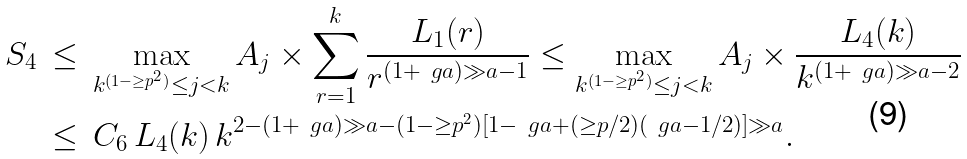<formula> <loc_0><loc_0><loc_500><loc_500>S _ { 4 } & \, \leq \, \max _ { k ^ { ( 1 - \geq p ^ { 2 } ) } \leq j < k } A _ { j } \times \sum _ { r = 1 } ^ { k } \frac { L _ { 1 } ( r ) } { r ^ { ( 1 + \ g a ) \gg a - 1 } } \leq \max _ { k ^ { ( 1 - \geq p ^ { 2 } ) } \leq j < k } A _ { j } \times \frac { L _ { 4 } ( k ) } { k ^ { ( 1 + \ g a ) \gg a - 2 } } \\ & \, \leq \, C _ { 6 } \, L _ { 4 } ( k ) \, k ^ { 2 - ( 1 + \ g a ) \gg a - ( 1 - \geq p ^ { 2 } ) [ 1 - \ g a + ( \geq p / 2 ) ( \ g a - 1 / 2 ) ] \gg a } .</formula> 